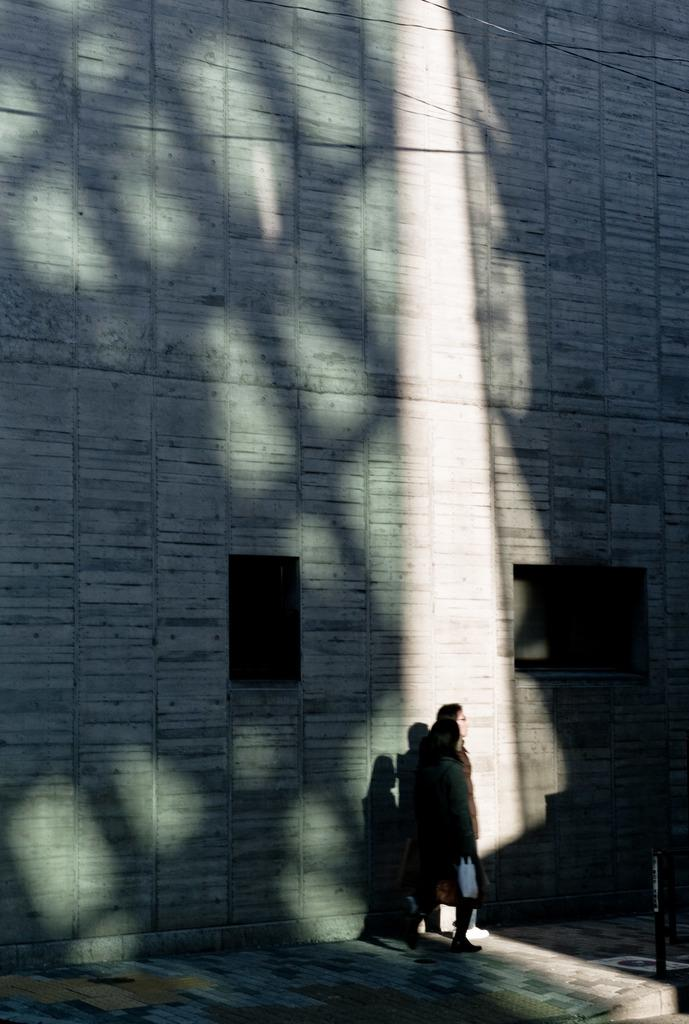How many people are in the image? There are two girls in the image. Where are the girls standing? The girls are standing on a footpath. What can be seen in the background of the image? There is a tall wall in the background of the image. What is at the top of the wall? There are wires at the top of the wall. What type of wax can be seen dripping from the fairies' wings in the image? There are no fairies or wax present in the image. How does the temper of the girls change throughout the image? The image does not depict any changes in the girls' temper or emotions. 